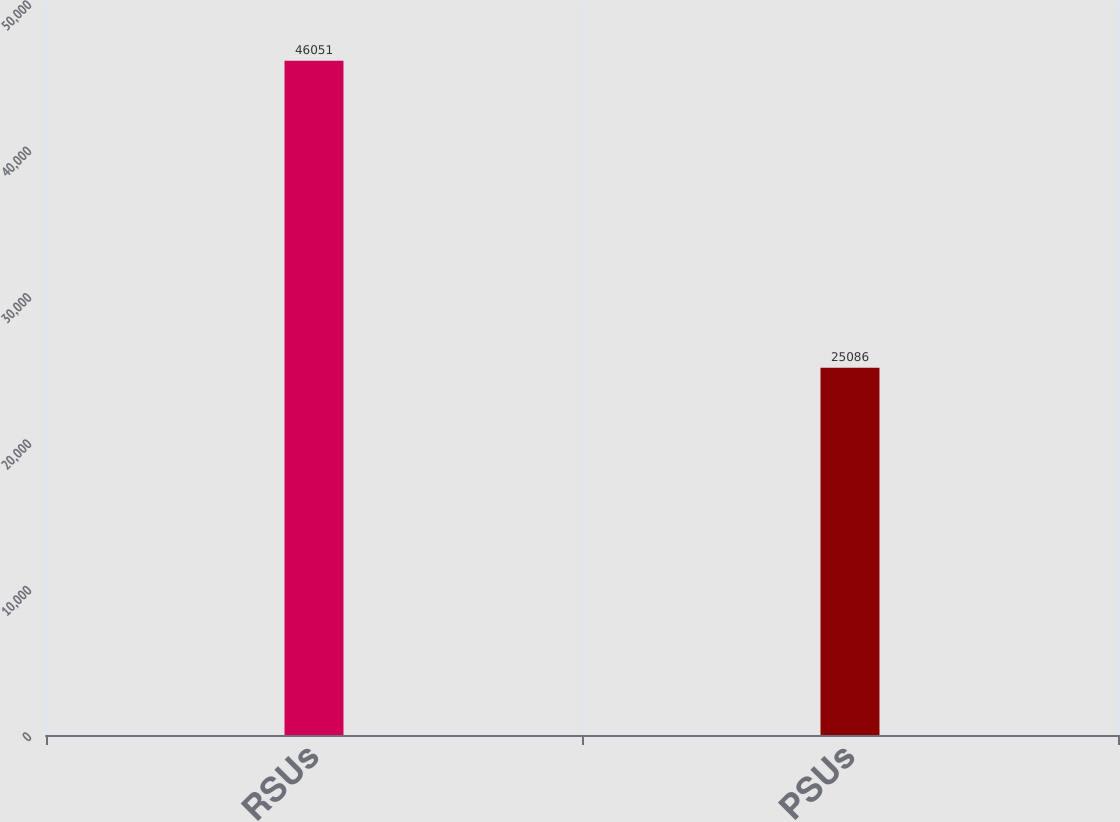Convert chart. <chart><loc_0><loc_0><loc_500><loc_500><bar_chart><fcel>RSUs<fcel>PSUs<nl><fcel>46051<fcel>25086<nl></chart> 